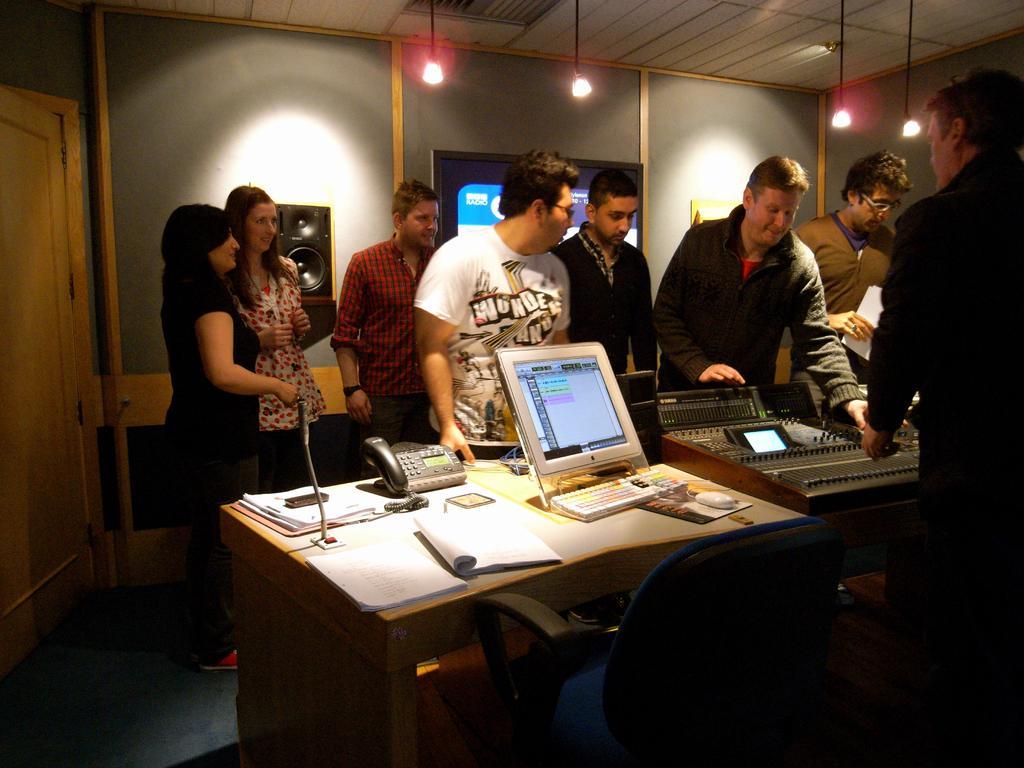Describe this image in one or two sentences. In the image we can see there are people who are standing and in front of them there is a table on which there is a monitor, telephone and other instrument. 